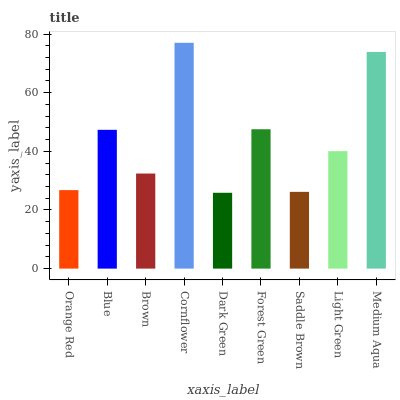Is Blue the minimum?
Answer yes or no. No. Is Blue the maximum?
Answer yes or no. No. Is Blue greater than Orange Red?
Answer yes or no. Yes. Is Orange Red less than Blue?
Answer yes or no. Yes. Is Orange Red greater than Blue?
Answer yes or no. No. Is Blue less than Orange Red?
Answer yes or no. No. Is Light Green the high median?
Answer yes or no. Yes. Is Light Green the low median?
Answer yes or no. Yes. Is Blue the high median?
Answer yes or no. No. Is Medium Aqua the low median?
Answer yes or no. No. 